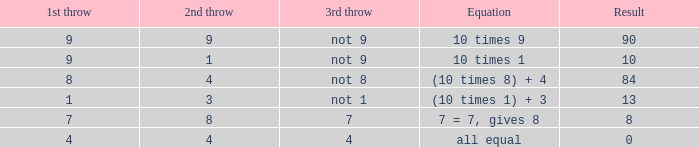What is the outcome if the third toss does not yield an 8? 84.0. 